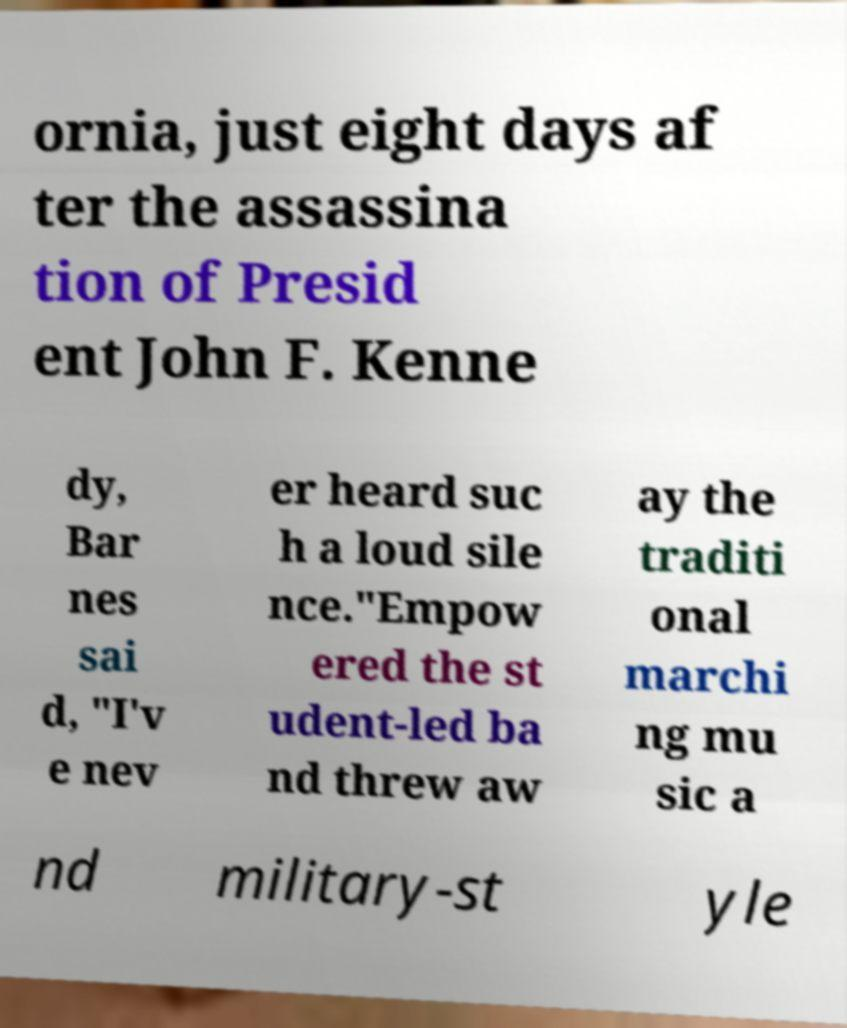Can you accurately transcribe the text from the provided image for me? ornia, just eight days af ter the assassina tion of Presid ent John F. Kenne dy, Bar nes sai d, "I'v e nev er heard suc h a loud sile nce."Empow ered the st udent-led ba nd threw aw ay the traditi onal marchi ng mu sic a nd military-st yle 